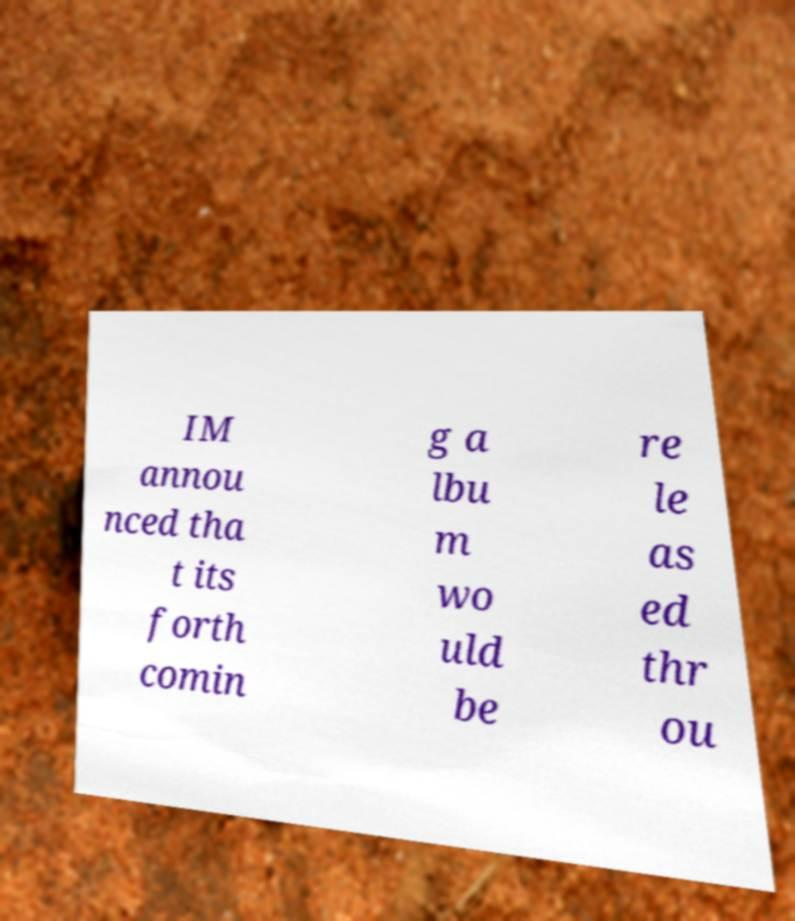There's text embedded in this image that I need extracted. Can you transcribe it verbatim? IM annou nced tha t its forth comin g a lbu m wo uld be re le as ed thr ou 